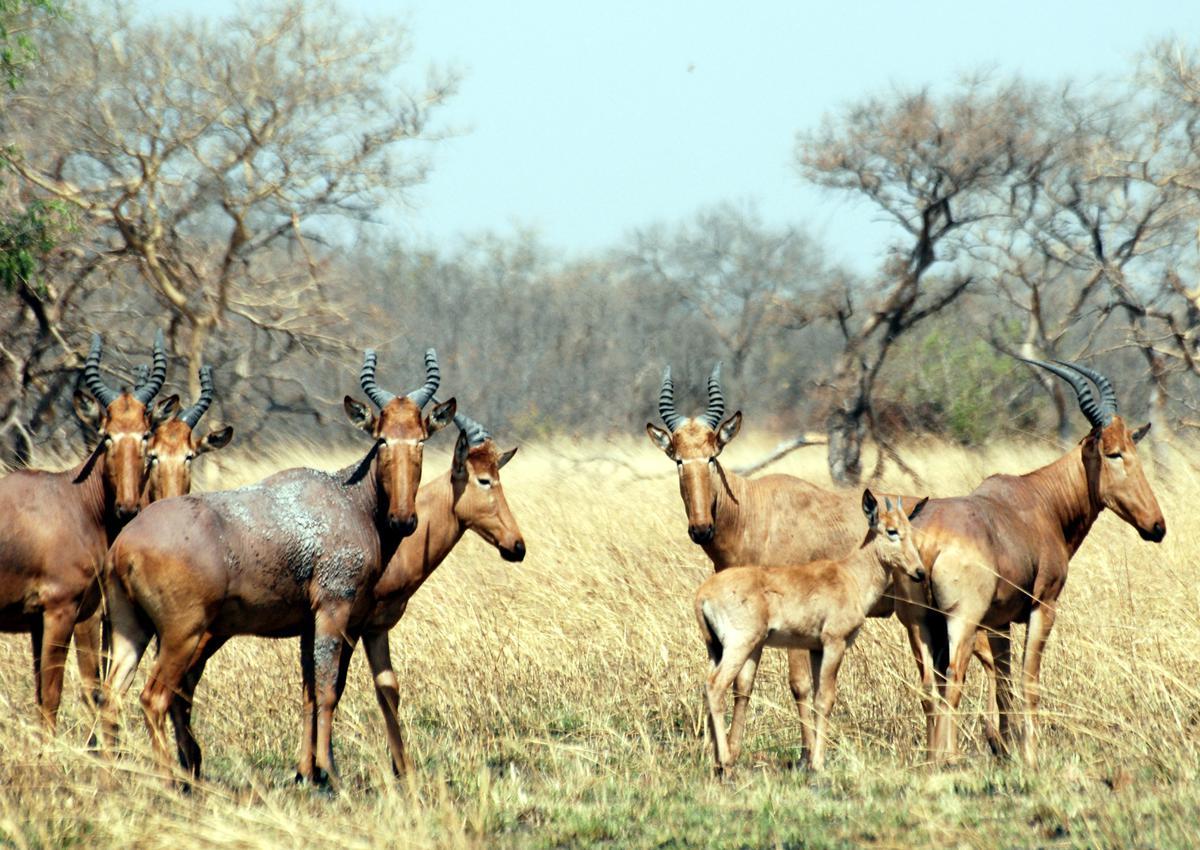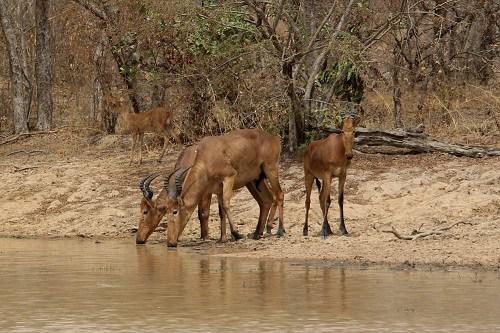The first image is the image on the left, the second image is the image on the right. Evaluate the accuracy of this statement regarding the images: "In at least one image, animals are drinking water.". Is it true? Answer yes or no. Yes. 